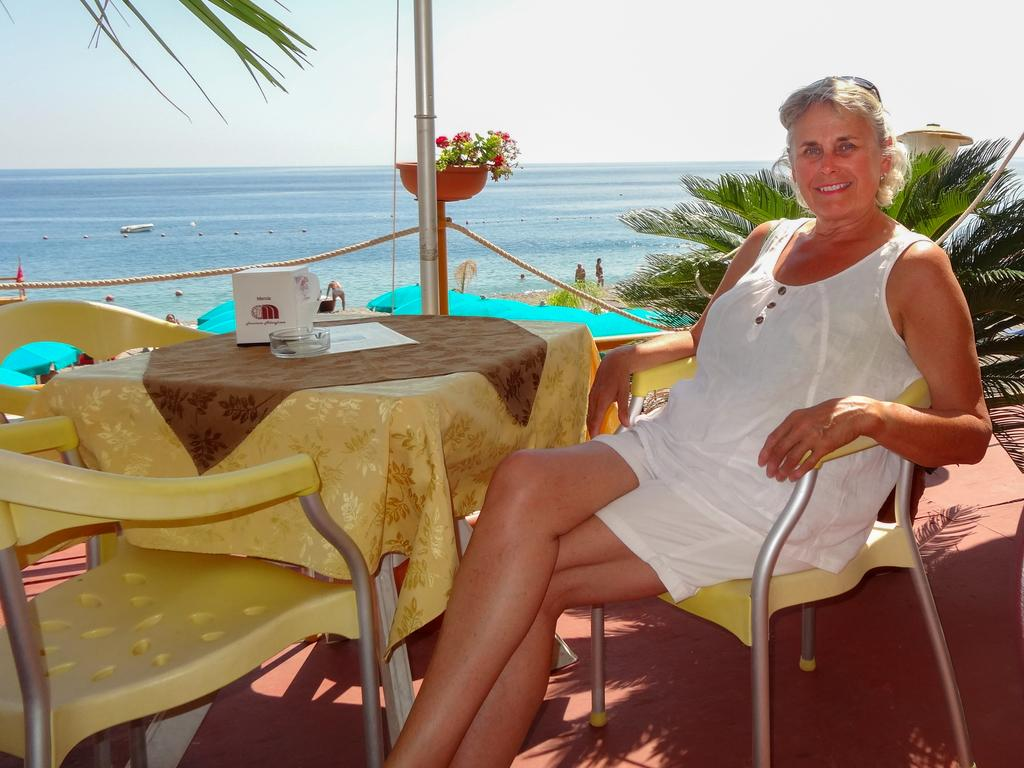What type of furniture is present in the image? There is a table in the image. What is the person in the image doing? The person is sitting on a chair. What can be seen in the background of the image? There are trees, a pole, a flower pot, a rope, and people visible in the background. What is the color of the sky in the image? The sky appears to be white in color. What type of animals can be seen at the airport in the image? There is no airport present in the image, and therefore no animals can be seen there. 